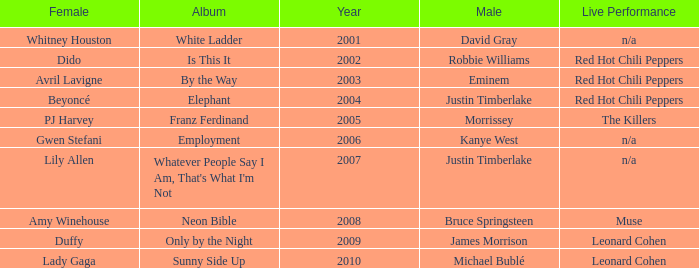Which male is paired with dido in 2004? Robbie Williams. 